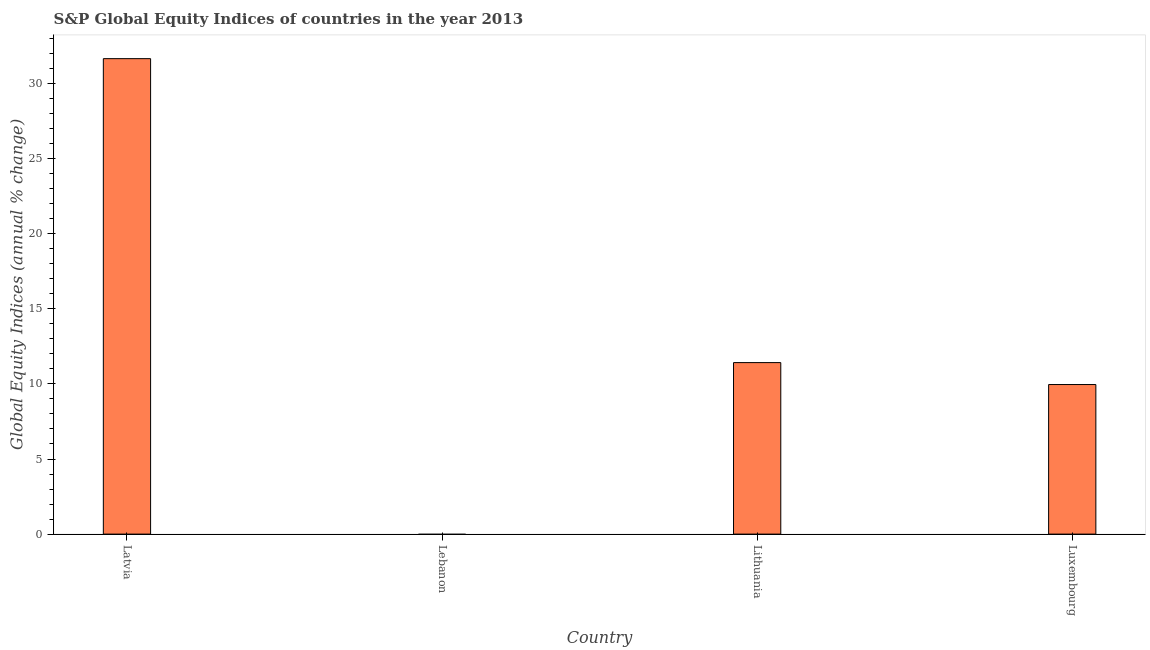Does the graph contain grids?
Make the answer very short. No. What is the title of the graph?
Your answer should be compact. S&P Global Equity Indices of countries in the year 2013. What is the label or title of the Y-axis?
Keep it short and to the point. Global Equity Indices (annual % change). Across all countries, what is the maximum s&p global equity indices?
Offer a very short reply. 31.66. In which country was the s&p global equity indices maximum?
Keep it short and to the point. Latvia. What is the sum of the s&p global equity indices?
Offer a very short reply. 53.04. What is the difference between the s&p global equity indices in Latvia and Luxembourg?
Your response must be concise. 21.7. What is the average s&p global equity indices per country?
Provide a succinct answer. 13.26. What is the median s&p global equity indices?
Provide a short and direct response. 10.69. In how many countries, is the s&p global equity indices greater than 5 %?
Ensure brevity in your answer.  3. What is the ratio of the s&p global equity indices in Latvia to that in Lithuania?
Your answer should be compact. 2.77. Is the s&p global equity indices in Lithuania less than that in Luxembourg?
Provide a succinct answer. No. Is the difference between the s&p global equity indices in Latvia and Luxembourg greater than the difference between any two countries?
Offer a very short reply. No. What is the difference between the highest and the second highest s&p global equity indices?
Offer a very short reply. 20.24. Is the sum of the s&p global equity indices in Latvia and Lithuania greater than the maximum s&p global equity indices across all countries?
Offer a terse response. Yes. What is the difference between the highest and the lowest s&p global equity indices?
Give a very brief answer. 31.66. In how many countries, is the s&p global equity indices greater than the average s&p global equity indices taken over all countries?
Give a very brief answer. 1. How many countries are there in the graph?
Provide a succinct answer. 4. What is the difference between two consecutive major ticks on the Y-axis?
Keep it short and to the point. 5. Are the values on the major ticks of Y-axis written in scientific E-notation?
Make the answer very short. No. What is the Global Equity Indices (annual % change) in Latvia?
Make the answer very short. 31.66. What is the Global Equity Indices (annual % change) in Lithuania?
Give a very brief answer. 11.42. What is the Global Equity Indices (annual % change) in Luxembourg?
Your answer should be compact. 9.96. What is the difference between the Global Equity Indices (annual % change) in Latvia and Lithuania?
Give a very brief answer. 20.24. What is the difference between the Global Equity Indices (annual % change) in Latvia and Luxembourg?
Your answer should be compact. 21.7. What is the difference between the Global Equity Indices (annual % change) in Lithuania and Luxembourg?
Offer a terse response. 1.46. What is the ratio of the Global Equity Indices (annual % change) in Latvia to that in Lithuania?
Make the answer very short. 2.77. What is the ratio of the Global Equity Indices (annual % change) in Latvia to that in Luxembourg?
Your response must be concise. 3.18. What is the ratio of the Global Equity Indices (annual % change) in Lithuania to that in Luxembourg?
Your answer should be compact. 1.15. 